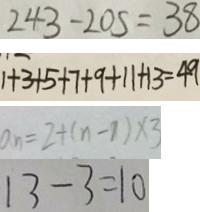<formula> <loc_0><loc_0><loc_500><loc_500>2 4 3 - 2 0 5 = 3 8 
 1 + 3 + 5 + 7 + 9 + 1 1 + 1 3 = 4 9 
 a _ { n } = 2 + ( n - 1 ) \times 3 
 1 3 - 3 = 1 0</formula> 